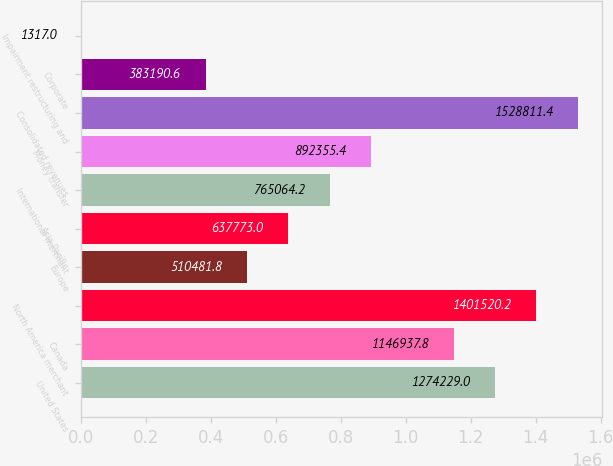Convert chart to OTSL. <chart><loc_0><loc_0><loc_500><loc_500><bar_chart><fcel>United States<fcel>Canada<fcel>North America merchant<fcel>Europe<fcel>Asia-Pacific<fcel>International merchant<fcel>Money transfer<fcel>Consolidated revenues<fcel>Corporate<fcel>Impairment restructuring and<nl><fcel>1.27423e+06<fcel>1.14694e+06<fcel>1.40152e+06<fcel>510482<fcel>637773<fcel>765064<fcel>892355<fcel>1.52881e+06<fcel>383191<fcel>1317<nl></chart> 